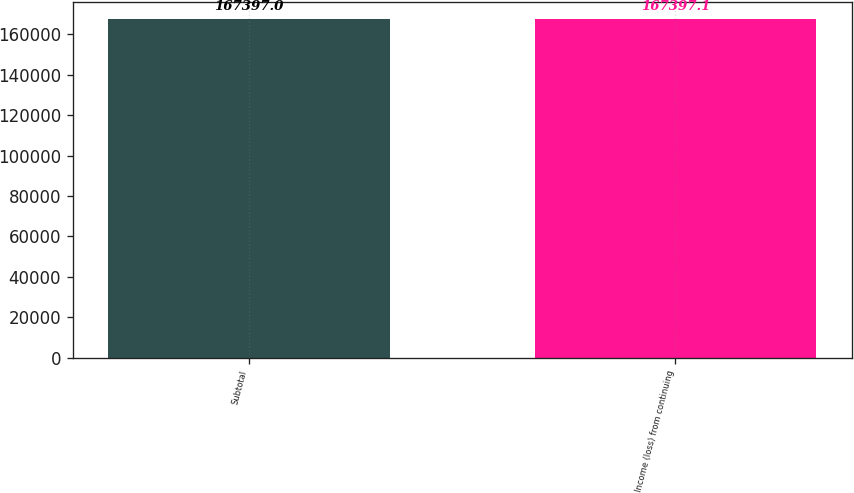Convert chart to OTSL. <chart><loc_0><loc_0><loc_500><loc_500><bar_chart><fcel>Subtotal<fcel>Income (loss) from continuing<nl><fcel>167397<fcel>167397<nl></chart> 